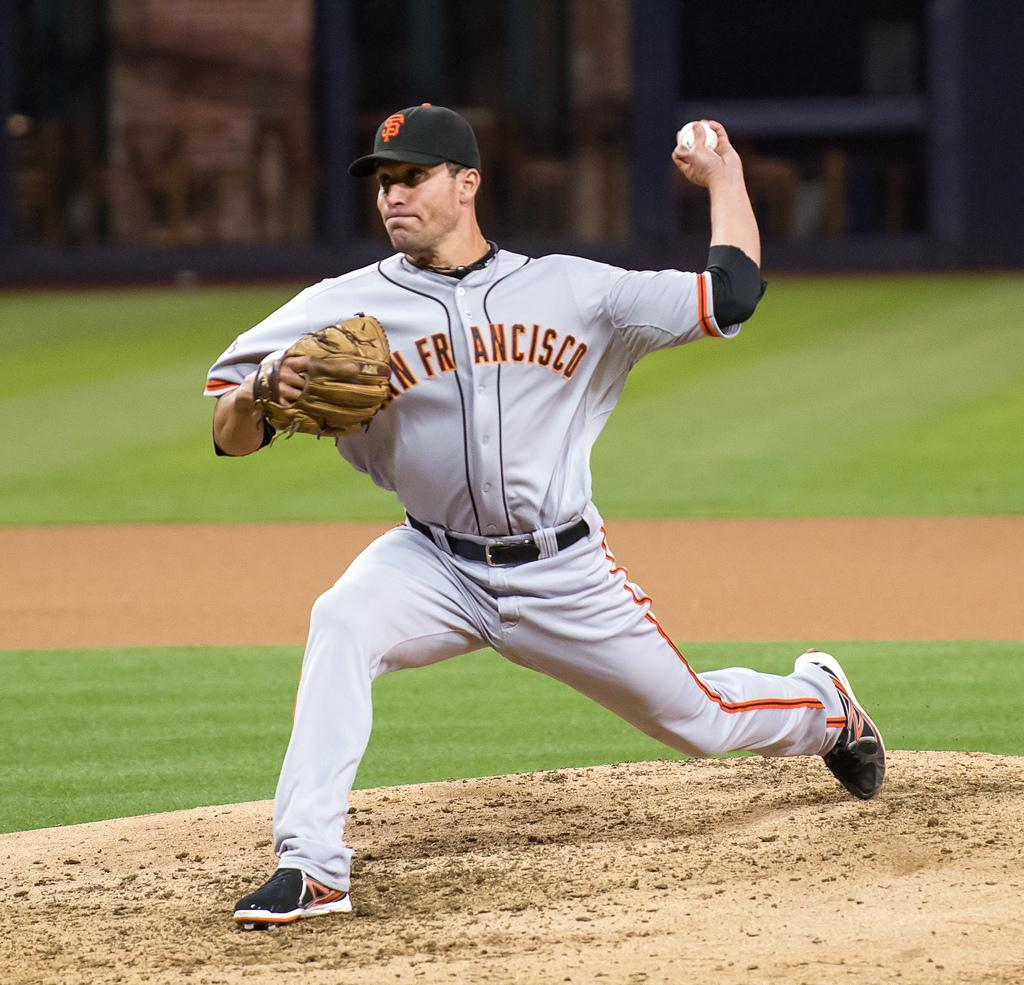<image>
Summarize the visual content of the image. A man can be seen in a San Francisco uniform pitching a ball. 